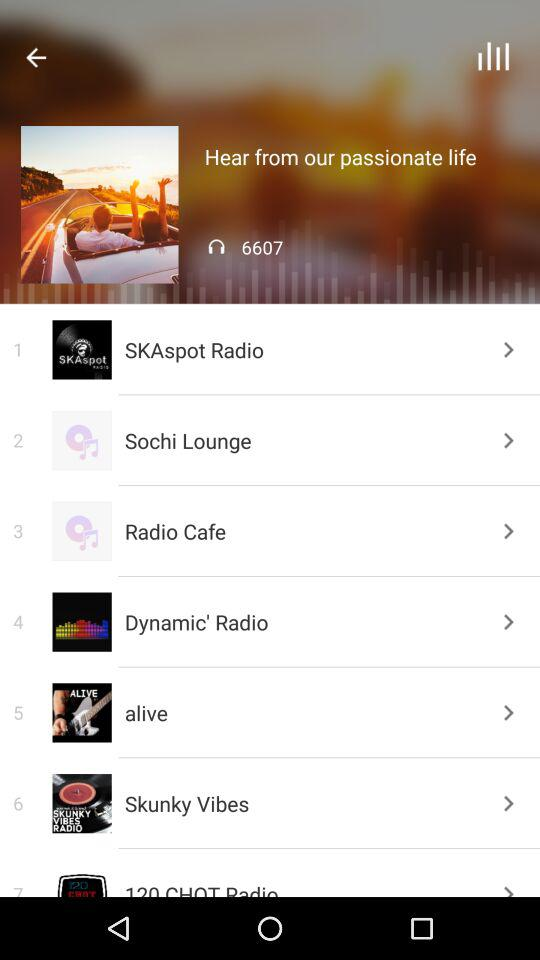What are the album titles? The album titles are "SKAspot Radio", "Sochi Lounge", "Radio Cafe", "Dynamic' Radio", "alive" and "Skunky Vibes". 